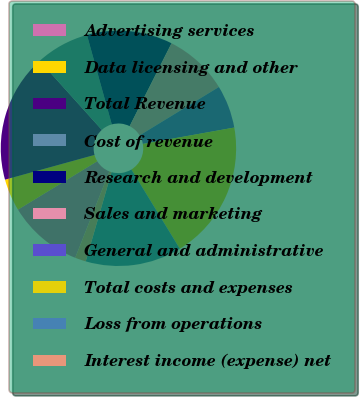<chart> <loc_0><loc_0><loc_500><loc_500><pie_chart><fcel>Advertising services<fcel>Data licensing and other<fcel>Total Revenue<fcel>Cost of revenue<fcel>Research and development<fcel>Sales and marketing<fcel>General and administrative<fcel>Total costs and expenses<fcel>Loss from operations<fcel>Interest income (expense) net<nl><fcel>10.29%<fcel>4.43%<fcel>17.62%<fcel>7.36%<fcel>11.76%<fcel>8.83%<fcel>5.9%<fcel>19.09%<fcel>13.22%<fcel>1.5%<nl></chart> 